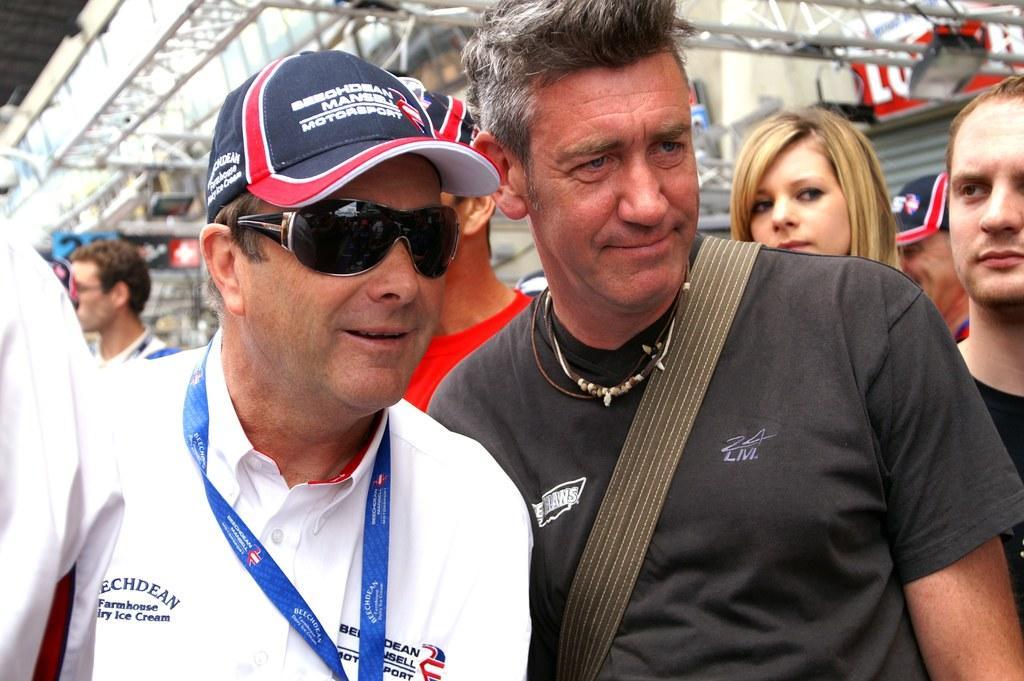Describe this image in one or two sentences. In this picture we can see some people are standing, the two persons in the front are smiling, in the background there are some metal rods, we can see a light at the right top of the picture. 